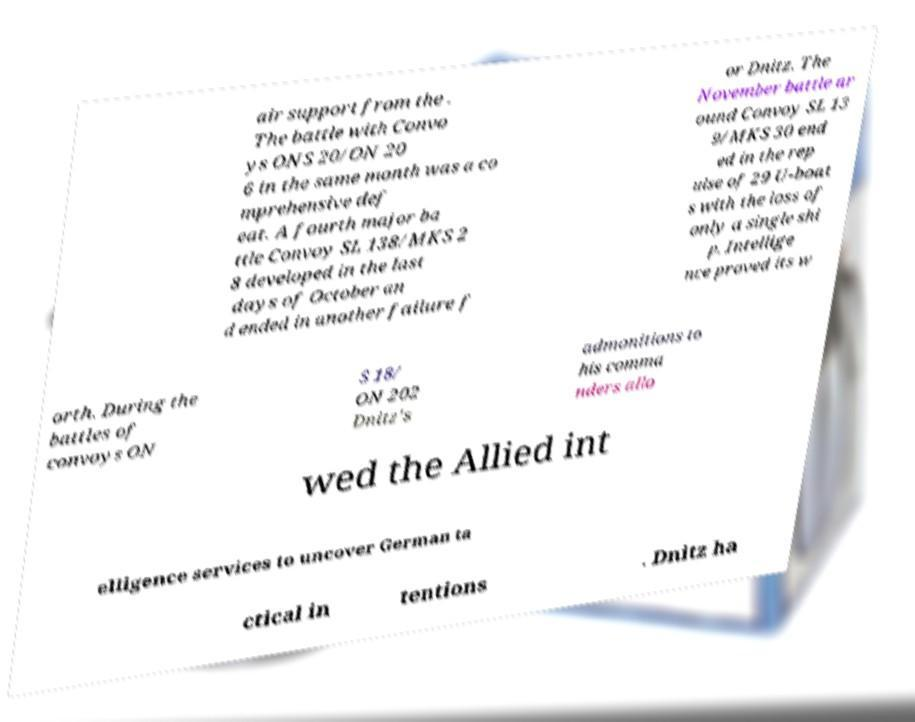Could you assist in decoding the text presented in this image and type it out clearly? air support from the . The battle with Convo ys ONS 20/ON 20 6 in the same month was a co mprehensive def eat. A fourth major ba ttle Convoy SL 138/MKS 2 8 developed in the last days of October an d ended in another failure f or Dnitz. The November battle ar ound Convoy SL 13 9/MKS 30 end ed in the rep ulse of 29 U-boat s with the loss of only a single shi p. Intellige nce proved its w orth. During the battles of convoys ON S 18/ ON 202 Dnitz's admonitions to his comma nders allo wed the Allied int elligence services to uncover German ta ctical in tentions . Dnitz ha 